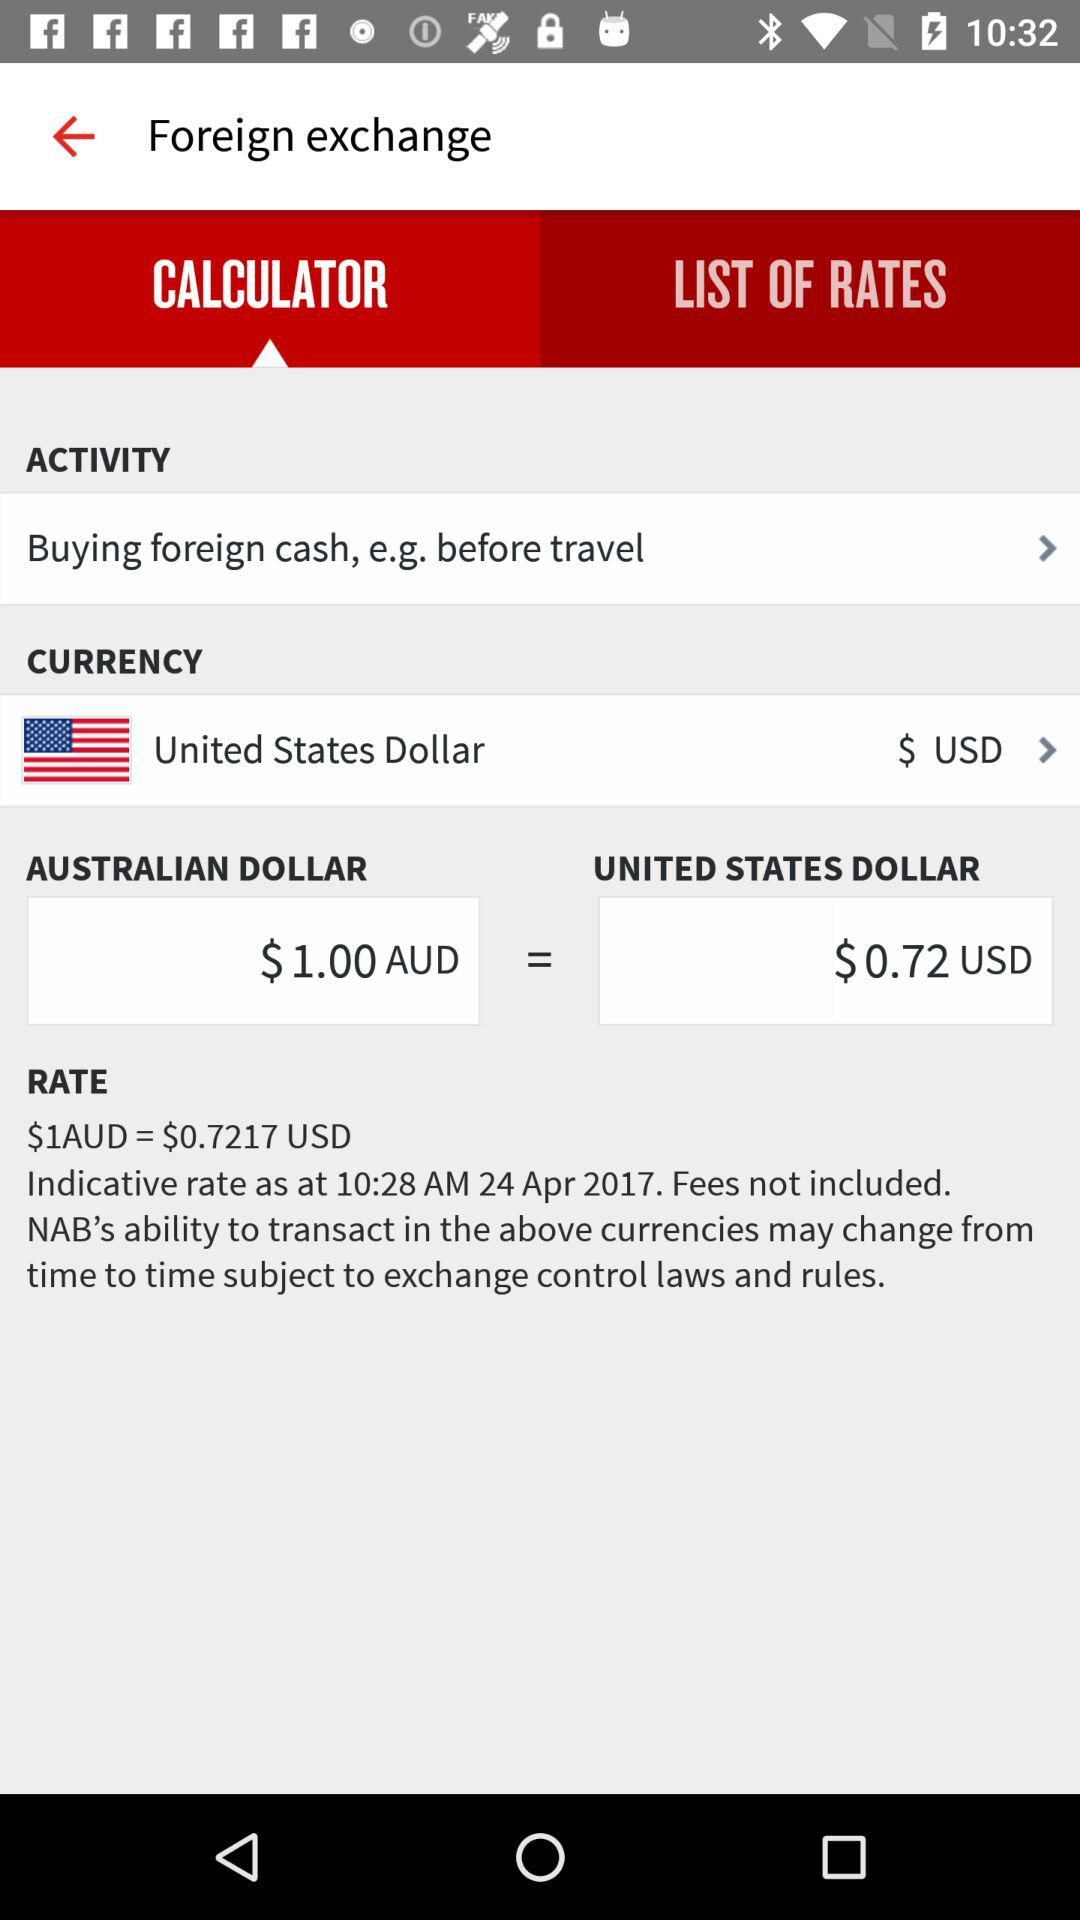What is the time and date of the indicative rate? The time is 10:28 AM and the date is April 24, 2017 of the indicative rate. 